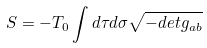Convert formula to latex. <formula><loc_0><loc_0><loc_500><loc_500>S = - T _ { 0 } \int d \tau d \sigma \sqrt { - d e t g _ { a b } }</formula> 